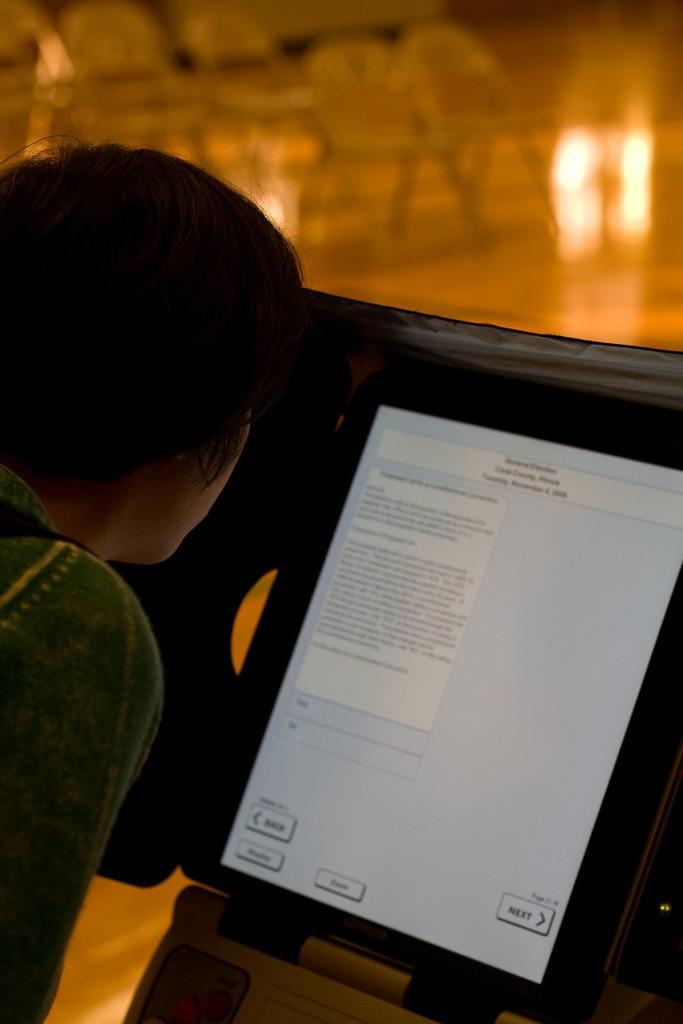In one or two sentences, can you explain what this image depicts? There is a person on the left side. In front of the person there is a screen with something written on it. In the background it is blurred. 